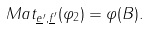<formula> <loc_0><loc_0><loc_500><loc_500>M a t _ { \underline { e } ^ { \prime } , \underline { f } ^ { \prime } } ( \varphi _ { 2 } ) = \varphi ( B ) .</formula> 